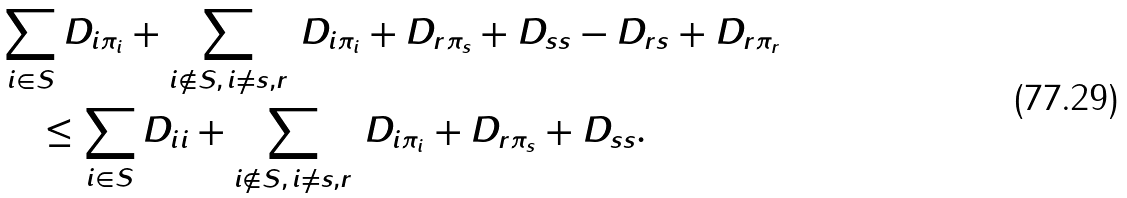Convert formula to latex. <formula><loc_0><loc_0><loc_500><loc_500>& \sum _ { i \in S } D _ { i \pi _ { i } } + \sum _ { i \not \in S , \, i \neq s , r } \, D _ { i \pi _ { i } } + D _ { r \pi _ { s } } + D _ { s s } - D _ { r s } + D _ { r \pi _ { r } } \\ & \quad \leq \sum _ { i \in S } D _ { i i } + \sum _ { i \not \in S , \, i \neq s , r } \, D _ { i \pi _ { i } } + D _ { r \pi _ { s } } + D _ { s s } .</formula> 